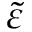Convert formula to latex. <formula><loc_0><loc_0><loc_500><loc_500>\tilde { \varepsilon }</formula> 